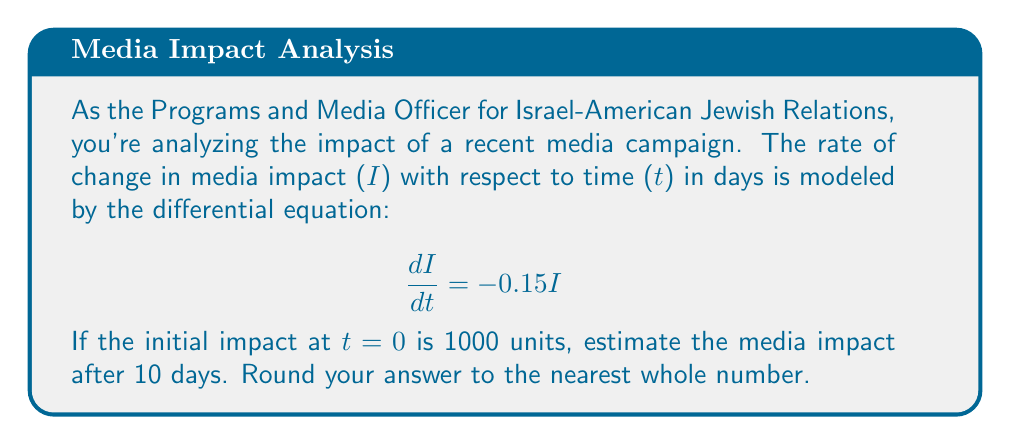Show me your answer to this math problem. 1) The given differential equation is a first-order linear equation:
   $$\frac{dI}{dt} = -0.15I$$

2) This equation represents exponential decay with a decay constant of 0.15.

3) The general solution for this type of equation is:
   $$I(t) = I_0e^{-kt}$$
   where $I_0$ is the initial impact and $k$ is the decay constant.

4) We're given:
   $I_0 = 1000$ (initial impact)
   $k = 0.15$ (decay constant)
   $t = 10$ (days)

5) Substituting these values into our solution:
   $$I(10) = 1000e^{-0.15(10)}$$

6) Calculating:
   $$I(10) = 1000e^{-1.5} \approx 223.13$$

7) Rounding to the nearest whole number:
   $I(10) \approx 223$ units
Answer: 223 units 